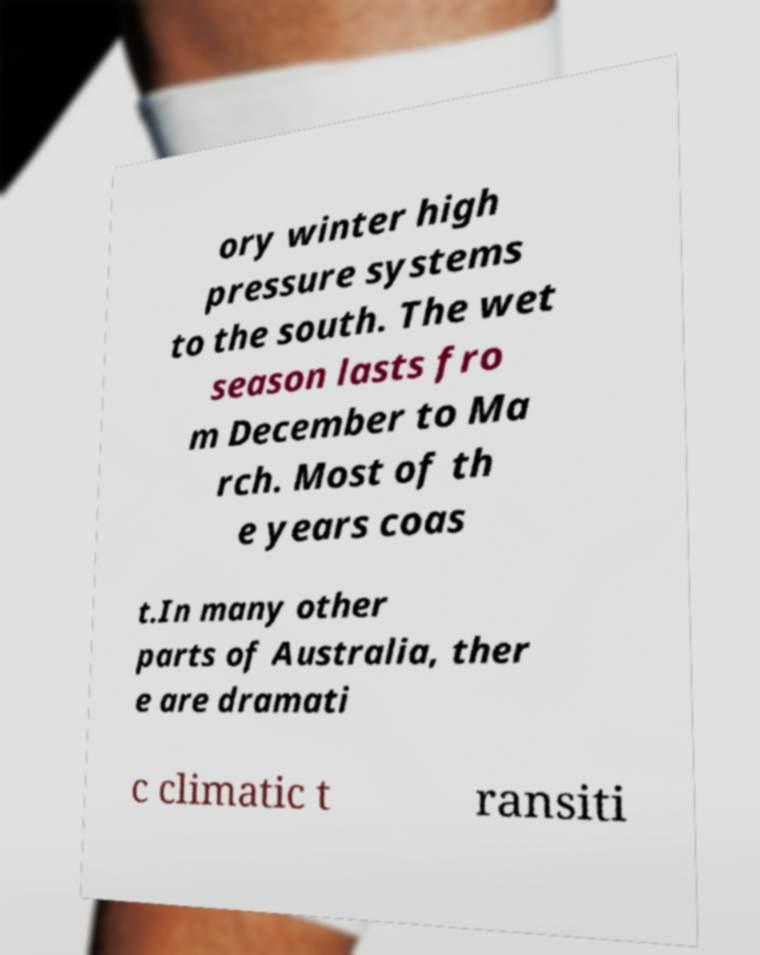I need the written content from this picture converted into text. Can you do that? ory winter high pressure systems to the south. The wet season lasts fro m December to Ma rch. Most of th e years coas t.In many other parts of Australia, ther e are dramati c climatic t ransiti 